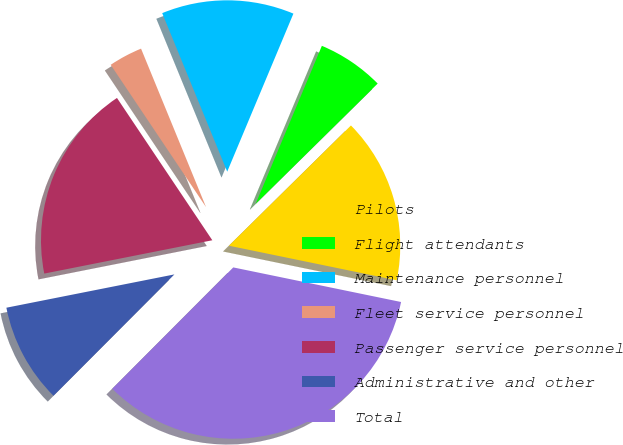Convert chart to OTSL. <chart><loc_0><loc_0><loc_500><loc_500><pie_chart><fcel>Pilots<fcel>Flight attendants<fcel>Maintenance personnel<fcel>Fleet service personnel<fcel>Passenger service personnel<fcel>Administrative and other<fcel>Total<nl><fcel>15.62%<fcel>6.3%<fcel>12.51%<fcel>3.2%<fcel>18.72%<fcel>9.41%<fcel>34.24%<nl></chart> 